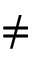<formula> <loc_0><loc_0><loc_500><loc_500>\neq</formula> 